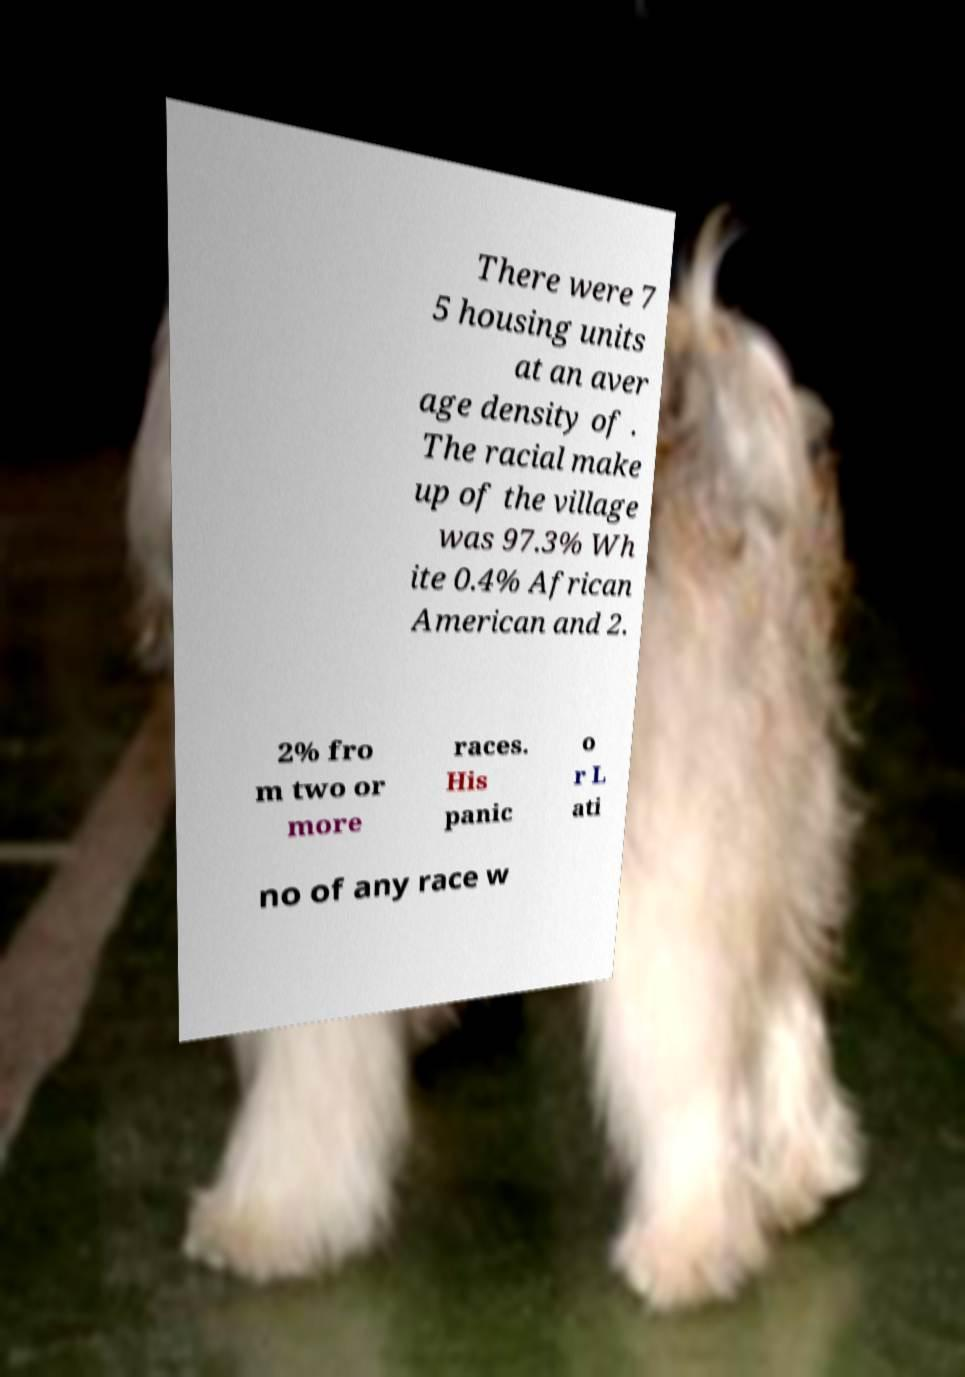Please read and relay the text visible in this image. What does it say? There were 7 5 housing units at an aver age density of . The racial make up of the village was 97.3% Wh ite 0.4% African American and 2. 2% fro m two or more races. His panic o r L ati no of any race w 